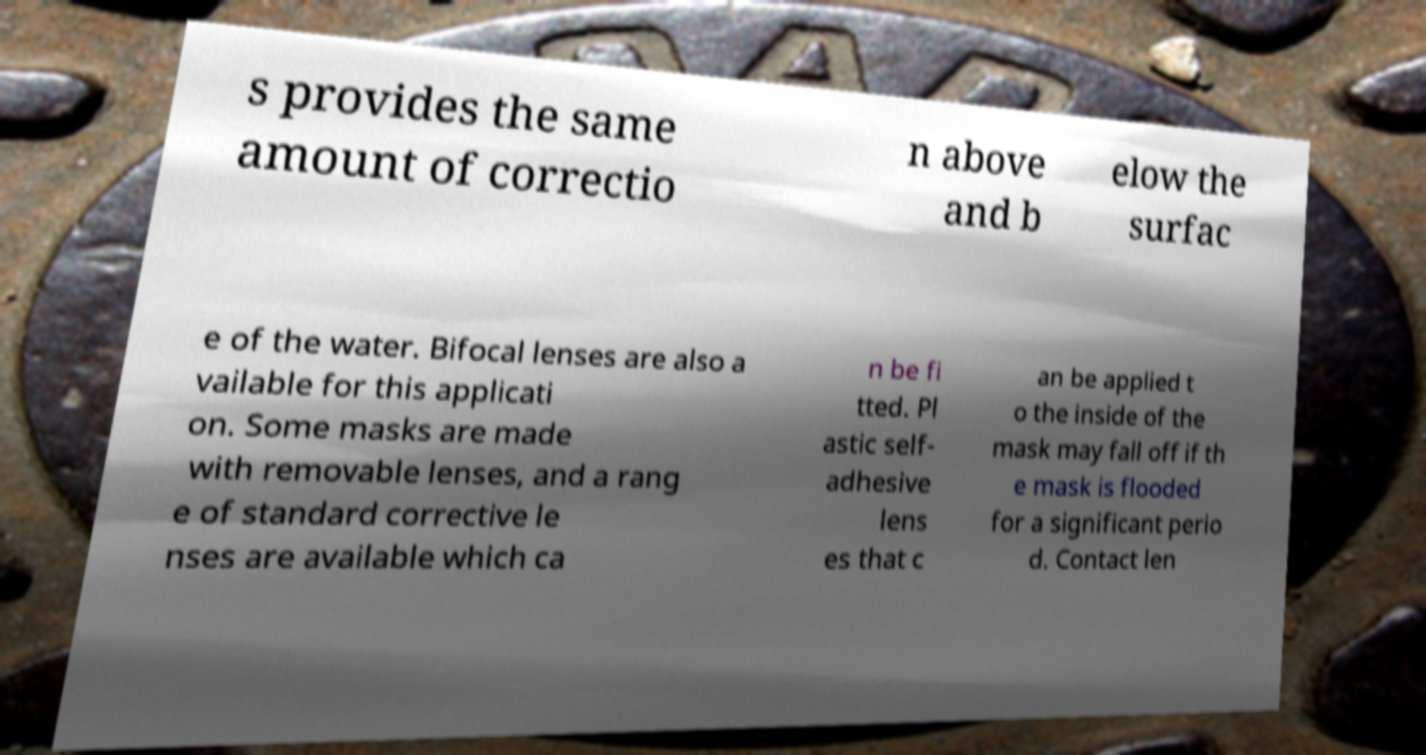Can you accurately transcribe the text from the provided image for me? s provides the same amount of correctio n above and b elow the surfac e of the water. Bifocal lenses are also a vailable for this applicati on. Some masks are made with removable lenses, and a rang e of standard corrective le nses are available which ca n be fi tted. Pl astic self- adhesive lens es that c an be applied t o the inside of the mask may fall off if th e mask is flooded for a significant perio d. Contact len 